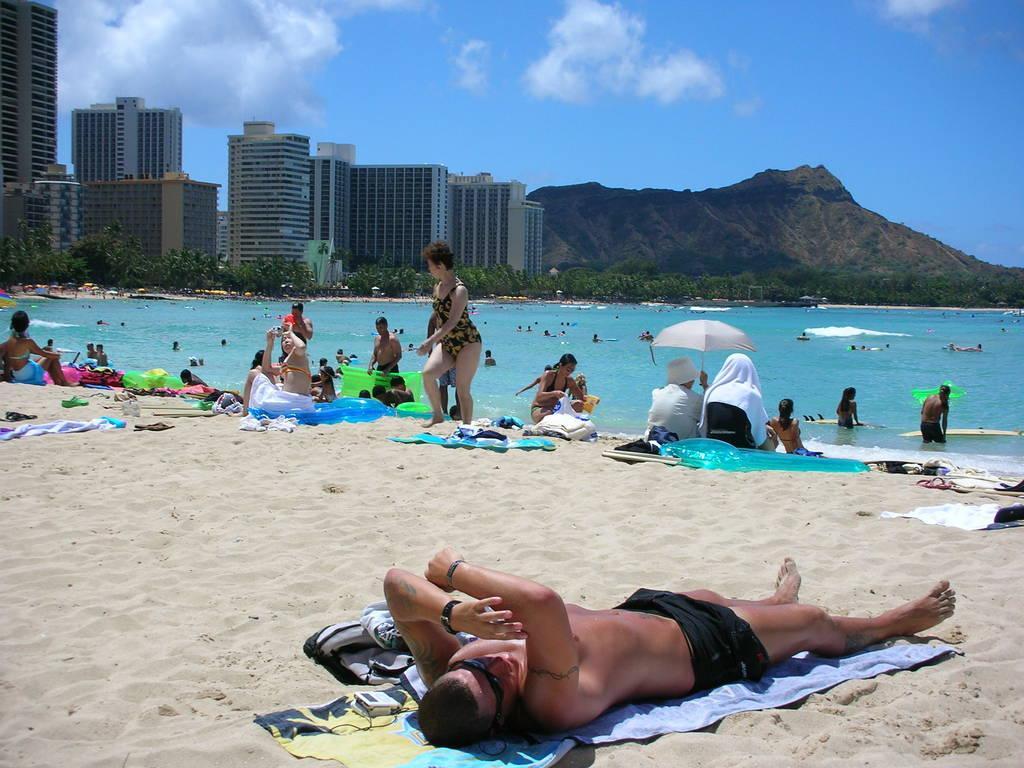Describe this image in one or two sentences. The picture is taken in a beach. In the foreground of the picture there are people, mats, clothes, umbrella, sand and many other objects. In the center of the picture there is a water body, in the water there are people. In the background there are buildings, trees and hill. Sky is sunny. 